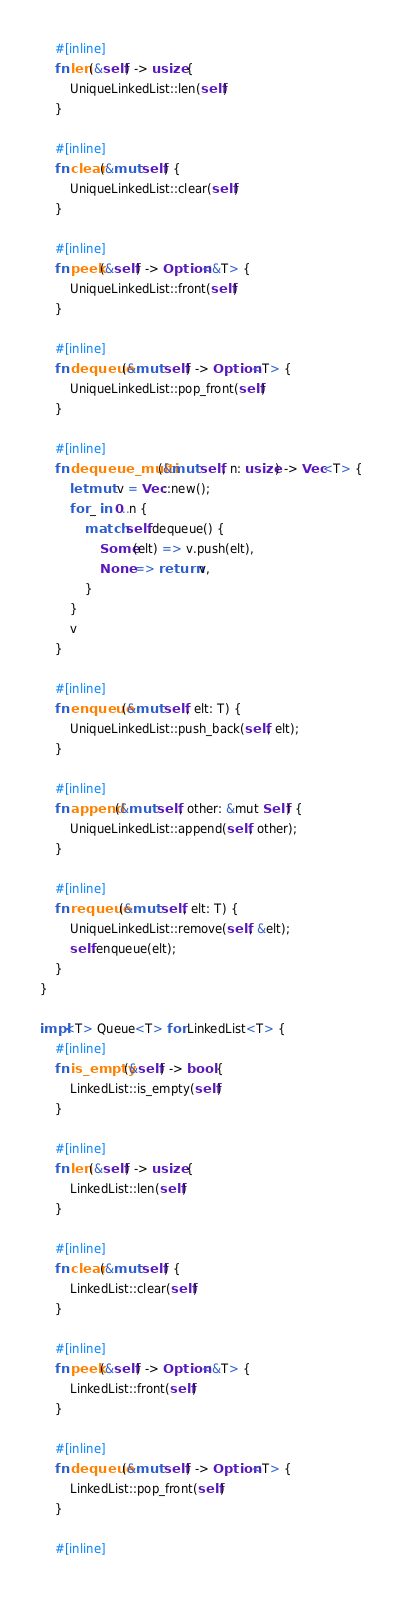<code> <loc_0><loc_0><loc_500><loc_500><_Rust_>    #[inline]
    fn len(&self) -> usize {
        UniqueLinkedList::len(self)
    }

    #[inline]
    fn clear(&mut self) {
        UniqueLinkedList::clear(self)
    }

    #[inline]
    fn peek(&self) -> Option<&T> {
        UniqueLinkedList::front(self)
    }

    #[inline]
    fn dequeue(&mut self) -> Option<T> {
        UniqueLinkedList::pop_front(self)
    }

    #[inline]
    fn dequeue_multi(&mut self, n: usize) -> Vec<T> {
        let mut v = Vec::new();
        for _ in 0..n {
            match self.dequeue() {
                Some(elt) => v.push(elt),
                None => return v,
            }
        }
        v
    }

    #[inline]
    fn enqueue(&mut self, elt: T) {
        UniqueLinkedList::push_back(self, elt);
    }

    #[inline]
    fn append(&mut self, other: &mut Self) {
        UniqueLinkedList::append(self, other);
    }

    #[inline]
    fn requeue(&mut self, elt: T) {
        UniqueLinkedList::remove(self, &elt);
        self.enqueue(elt);
    }
}

impl<T> Queue<T> for LinkedList<T> {
    #[inline]
    fn is_empty(&self) -> bool {
        LinkedList::is_empty(self)
    }

    #[inline]
    fn len(&self) -> usize {
        LinkedList::len(self)
    }

    #[inline]
    fn clear(&mut self) {
        LinkedList::clear(self)
    }

    #[inline]
    fn peek(&self) -> Option<&T> {
        LinkedList::front(self)
    }

    #[inline]
    fn dequeue(&mut self) -> Option<T> {
        LinkedList::pop_front(self)
    }

    #[inline]</code> 